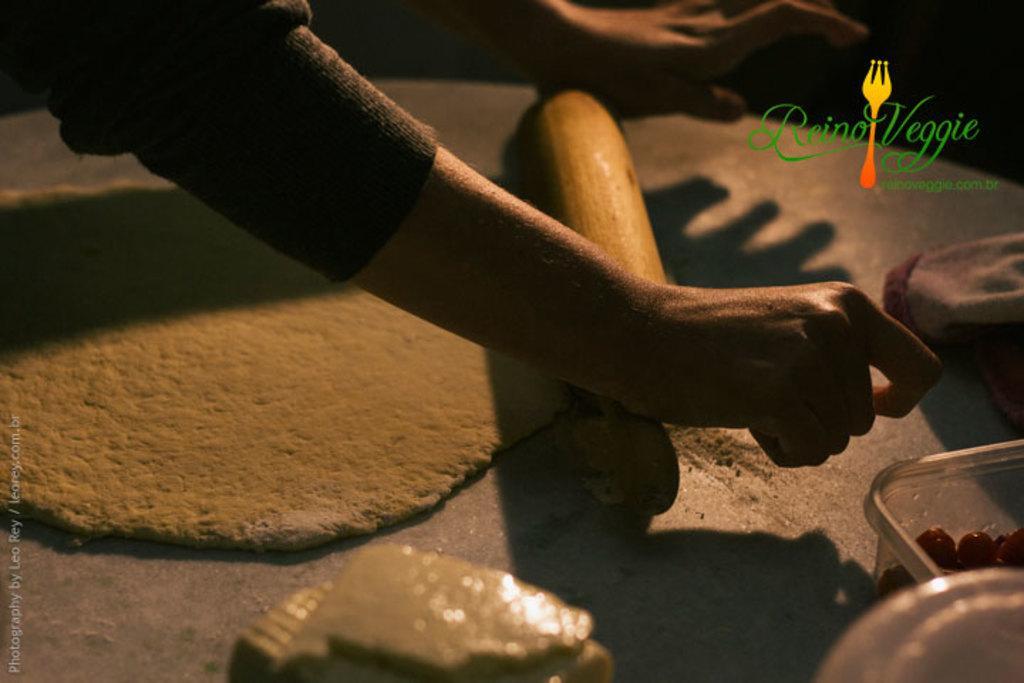Can you describe this image briefly? In this image I can see a person's hands. Here I can see food item, plastic objects and other objects on the surface. Here I can see a logo on the image. 